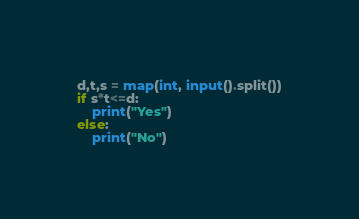<code> <loc_0><loc_0><loc_500><loc_500><_Python_>d,t,s = map(int, input().split())
if s*t<=d:
    print("Yes")
else:
    print("No")</code> 